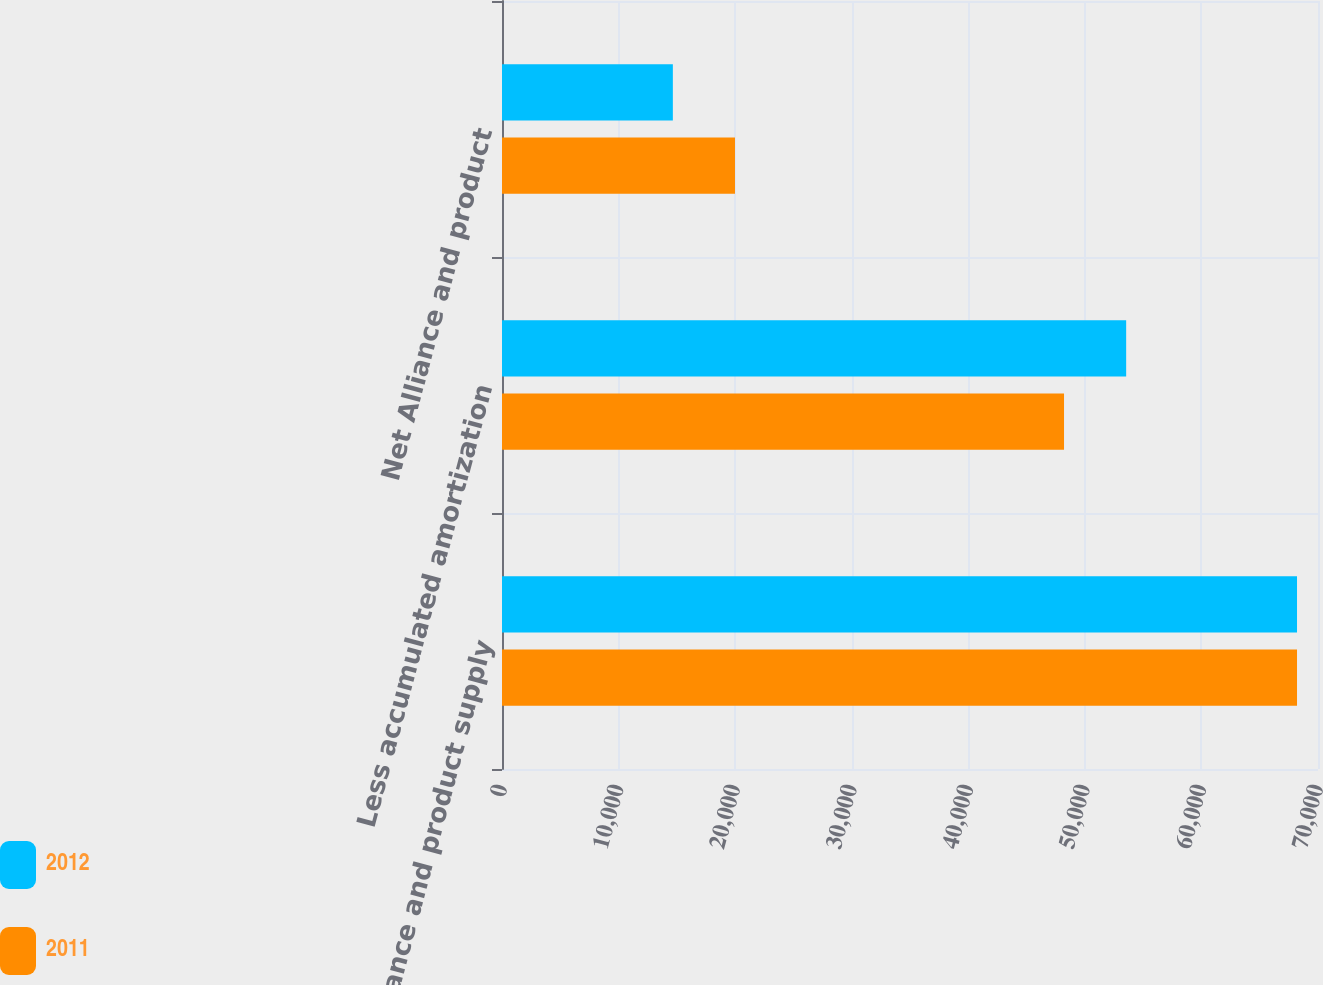Convert chart to OTSL. <chart><loc_0><loc_0><loc_500><loc_500><stacked_bar_chart><ecel><fcel>Alliance and product supply<fcel>Less accumulated amortization<fcel>Net Alliance and product<nl><fcel>2012<fcel>68200<fcel>53543<fcel>14657<nl><fcel>2011<fcel>68200<fcel>48213<fcel>19987<nl></chart> 